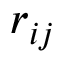Convert formula to latex. <formula><loc_0><loc_0><loc_500><loc_500>r _ { i j }</formula> 